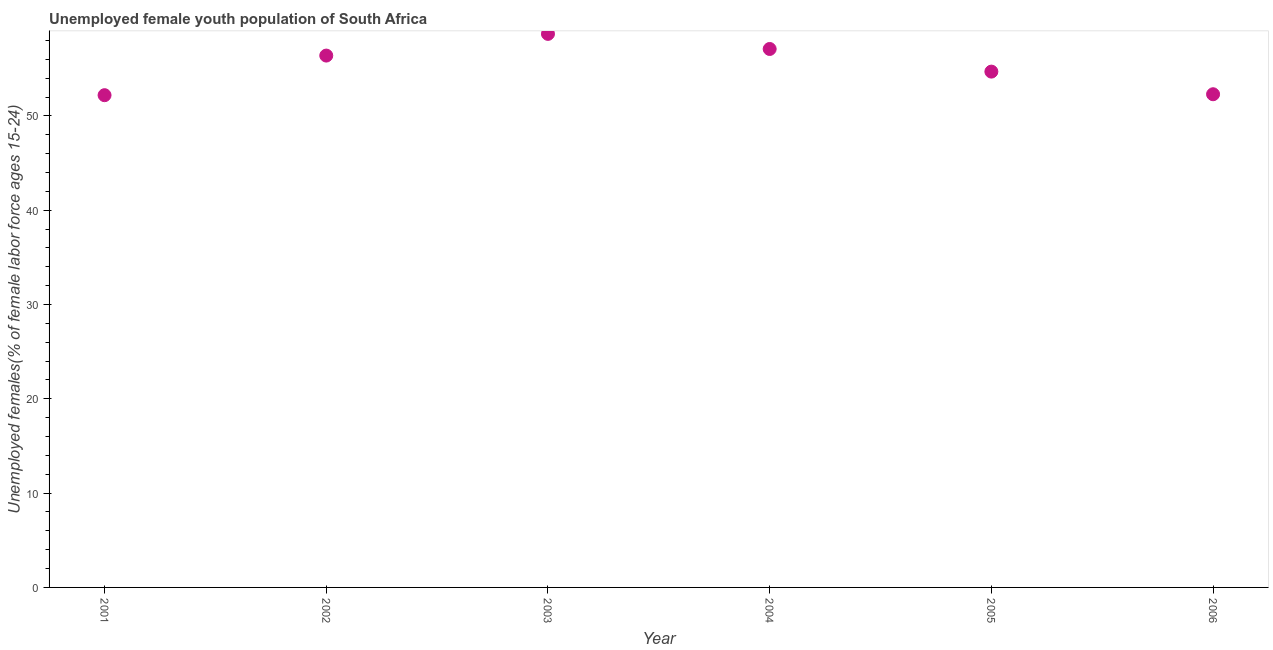What is the unemployed female youth in 2003?
Provide a succinct answer. 58.7. Across all years, what is the maximum unemployed female youth?
Give a very brief answer. 58.7. Across all years, what is the minimum unemployed female youth?
Your answer should be compact. 52.2. In which year was the unemployed female youth maximum?
Provide a succinct answer. 2003. In which year was the unemployed female youth minimum?
Make the answer very short. 2001. What is the sum of the unemployed female youth?
Offer a very short reply. 331.4. What is the difference between the unemployed female youth in 2002 and 2003?
Make the answer very short. -2.3. What is the average unemployed female youth per year?
Your answer should be compact. 55.23. What is the median unemployed female youth?
Keep it short and to the point. 55.55. What is the ratio of the unemployed female youth in 2002 to that in 2006?
Your answer should be very brief. 1.08. Is the unemployed female youth in 2001 less than that in 2006?
Offer a very short reply. Yes. What is the difference between the highest and the second highest unemployed female youth?
Offer a very short reply. 1.6. What is the difference between two consecutive major ticks on the Y-axis?
Offer a very short reply. 10. Are the values on the major ticks of Y-axis written in scientific E-notation?
Ensure brevity in your answer.  No. Does the graph contain any zero values?
Your response must be concise. No. Does the graph contain grids?
Ensure brevity in your answer.  No. What is the title of the graph?
Provide a short and direct response. Unemployed female youth population of South Africa. What is the label or title of the X-axis?
Give a very brief answer. Year. What is the label or title of the Y-axis?
Your response must be concise. Unemployed females(% of female labor force ages 15-24). What is the Unemployed females(% of female labor force ages 15-24) in 2001?
Offer a terse response. 52.2. What is the Unemployed females(% of female labor force ages 15-24) in 2002?
Your answer should be compact. 56.4. What is the Unemployed females(% of female labor force ages 15-24) in 2003?
Provide a succinct answer. 58.7. What is the Unemployed females(% of female labor force ages 15-24) in 2004?
Provide a short and direct response. 57.1. What is the Unemployed females(% of female labor force ages 15-24) in 2005?
Your response must be concise. 54.7. What is the Unemployed females(% of female labor force ages 15-24) in 2006?
Your answer should be compact. 52.3. What is the difference between the Unemployed females(% of female labor force ages 15-24) in 2001 and 2005?
Your answer should be very brief. -2.5. What is the difference between the Unemployed females(% of female labor force ages 15-24) in 2002 and 2003?
Keep it short and to the point. -2.3. What is the difference between the Unemployed females(% of female labor force ages 15-24) in 2002 and 2004?
Your answer should be compact. -0.7. What is the difference between the Unemployed females(% of female labor force ages 15-24) in 2002 and 2006?
Your response must be concise. 4.1. What is the difference between the Unemployed females(% of female labor force ages 15-24) in 2003 and 2004?
Your answer should be very brief. 1.6. What is the difference between the Unemployed females(% of female labor force ages 15-24) in 2004 and 2005?
Provide a succinct answer. 2.4. What is the difference between the Unemployed females(% of female labor force ages 15-24) in 2004 and 2006?
Offer a very short reply. 4.8. What is the difference between the Unemployed females(% of female labor force ages 15-24) in 2005 and 2006?
Make the answer very short. 2.4. What is the ratio of the Unemployed females(% of female labor force ages 15-24) in 2001 to that in 2002?
Provide a succinct answer. 0.93. What is the ratio of the Unemployed females(% of female labor force ages 15-24) in 2001 to that in 2003?
Your answer should be compact. 0.89. What is the ratio of the Unemployed females(% of female labor force ages 15-24) in 2001 to that in 2004?
Give a very brief answer. 0.91. What is the ratio of the Unemployed females(% of female labor force ages 15-24) in 2001 to that in 2005?
Your answer should be very brief. 0.95. What is the ratio of the Unemployed females(% of female labor force ages 15-24) in 2001 to that in 2006?
Your answer should be very brief. 1. What is the ratio of the Unemployed females(% of female labor force ages 15-24) in 2002 to that in 2003?
Give a very brief answer. 0.96. What is the ratio of the Unemployed females(% of female labor force ages 15-24) in 2002 to that in 2004?
Give a very brief answer. 0.99. What is the ratio of the Unemployed females(% of female labor force ages 15-24) in 2002 to that in 2005?
Make the answer very short. 1.03. What is the ratio of the Unemployed females(% of female labor force ages 15-24) in 2002 to that in 2006?
Provide a short and direct response. 1.08. What is the ratio of the Unemployed females(% of female labor force ages 15-24) in 2003 to that in 2004?
Keep it short and to the point. 1.03. What is the ratio of the Unemployed females(% of female labor force ages 15-24) in 2003 to that in 2005?
Your response must be concise. 1.07. What is the ratio of the Unemployed females(% of female labor force ages 15-24) in 2003 to that in 2006?
Provide a short and direct response. 1.12. What is the ratio of the Unemployed females(% of female labor force ages 15-24) in 2004 to that in 2005?
Make the answer very short. 1.04. What is the ratio of the Unemployed females(% of female labor force ages 15-24) in 2004 to that in 2006?
Your answer should be very brief. 1.09. What is the ratio of the Unemployed females(% of female labor force ages 15-24) in 2005 to that in 2006?
Your answer should be very brief. 1.05. 